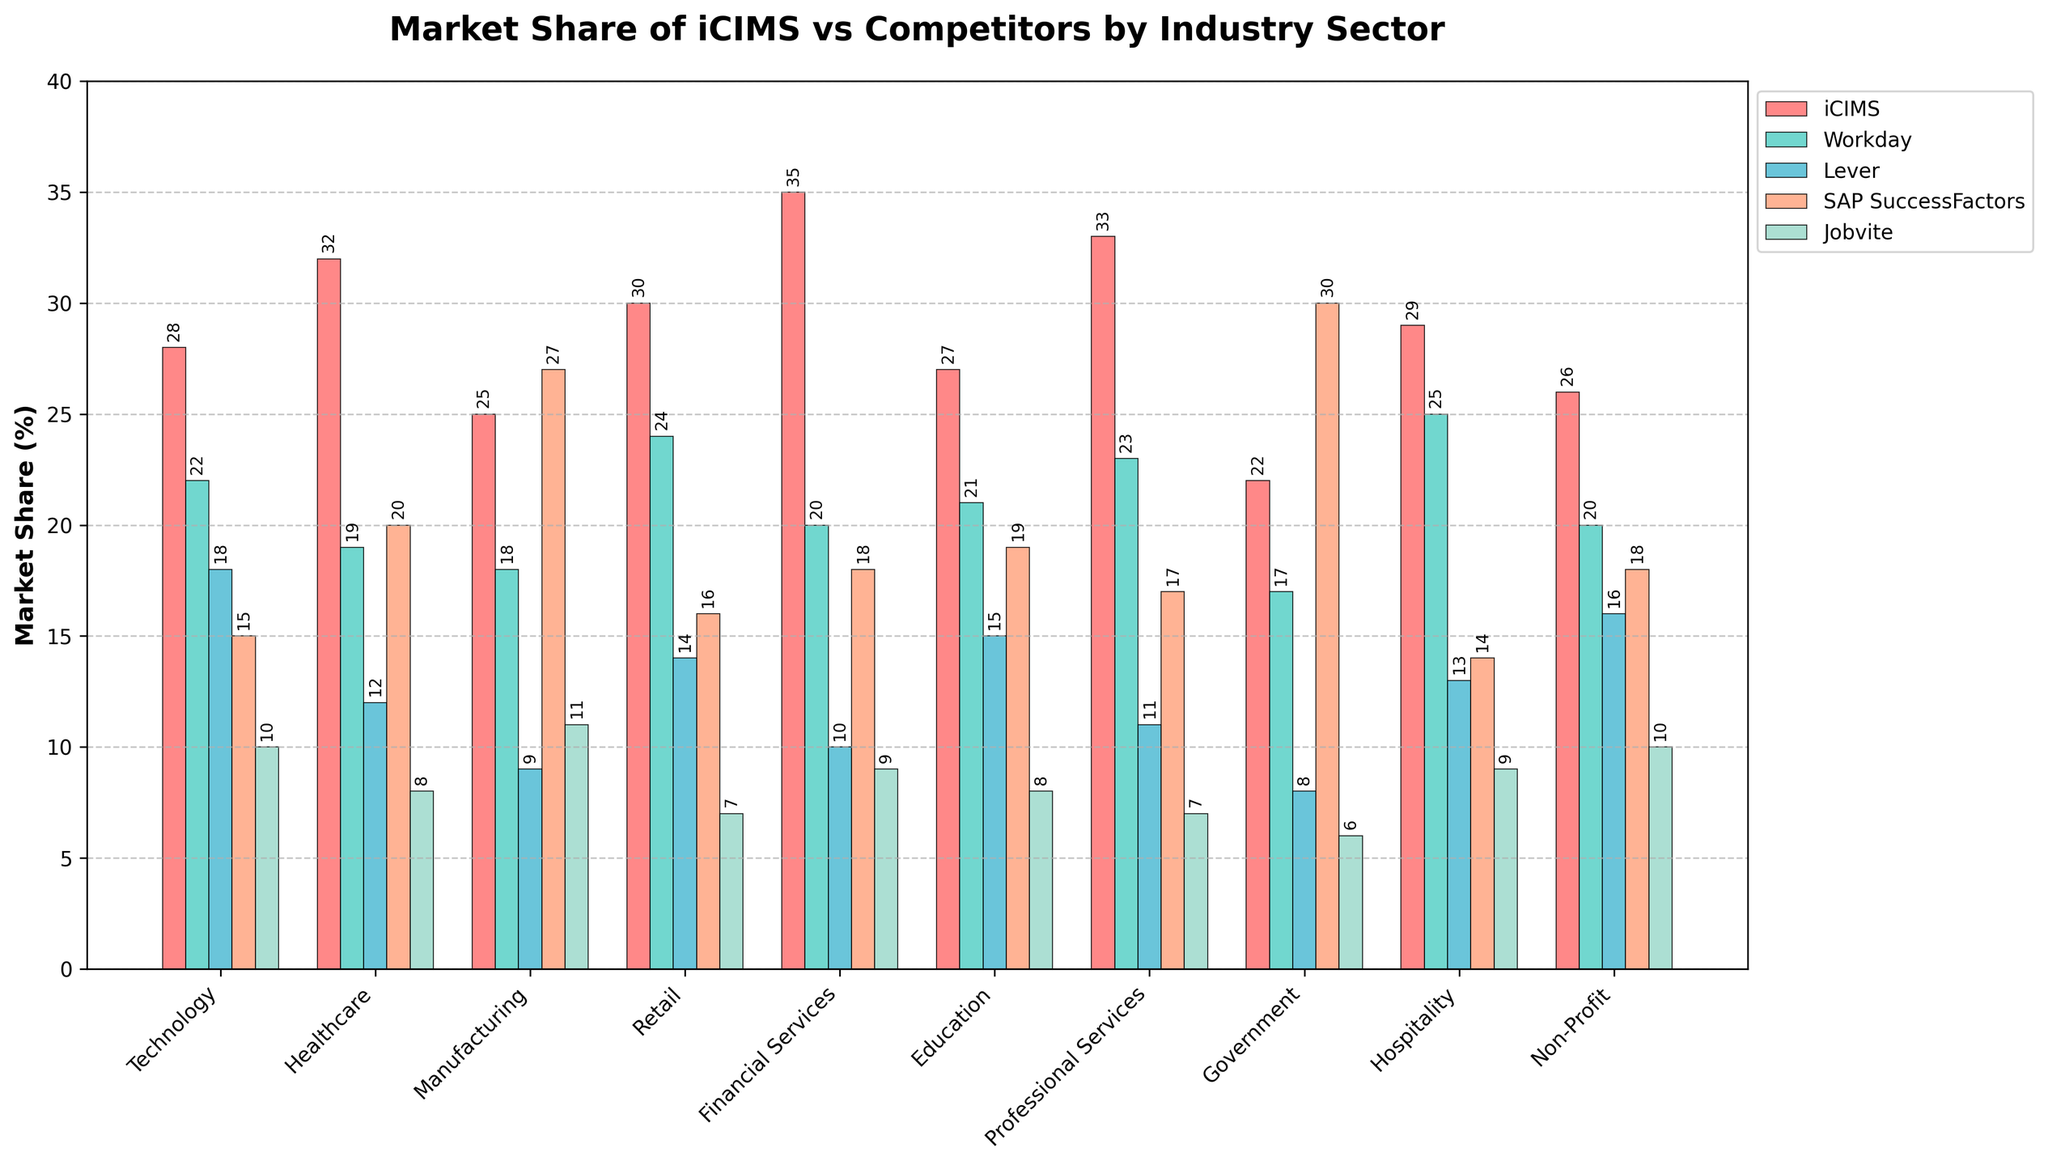What is the market share difference between iCIMS and SAP SuccessFactors in the Manufacturing sector? iCIMS has a 25% share, while SAP SuccessFactors has 27% in Manufacturing. The difference is 27% - 25%.
Answer: 2% Which company has the highest market share in the Healthcare sector? By observing the Healthcare sector bars, iCIMS has the highest market share with 32%.
Answer: iCIMS How does the market share of Jobvite in Retail compare to its share in Hospitality? Jobvite's market share in Retail is 7%, and in Hospitality, it is 9%. The share in Hospitality is higher.
Answer: Higher in Hospitality What is the combined market share of iCIMS in the Technology and Non-Profit sectors? iCIMS has a 28% share in Technology and a 26% share in Non-Profit. The sum is 28% + 26%.
Answer: 54% For the Government sector, which company has the lowest market share and what is it? By observing the Government sector bars, Jobvite has the lowest market share with 6%.
Answer: Jobvite, 6% Compare the total market share of Lever across all sectors to that of Workday. Add Lever's shares (18+12+9+14+10+15+11+8+13+16) and Workday's shares (22+19+18+24+20+21+23+17+25+20). Lever's total is 136% and Workday's total is 189%.
Answer: Workday, 189% In the Financial Services sector, what is the market share ratio of iCIMS to Lever? iCIMS has a 35% share, and Lever has a 10% share. The ratio is 35:10 or simplified as 7:2.
Answer: 7:2 Which sector shows the highest market share for SAP SuccessFactors, and what is that share? Observing the heights of the bars, Government with SAP SuccessFactors having 30% share is the highest.
Answer: Government, 30% What is the average market share of iCIMS across all sectors? Sum iCIMS shares across sectors (28+32+25+30+35+27+33+22+29+26) which is 287, and divide by the number of sectors (10).
Answer: 28.7% 